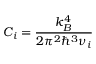<formula> <loc_0><loc_0><loc_500><loc_500>C _ { i } = \frac { k _ { B } ^ { 4 } } { 2 \pi ^ { 2 } \hbar { ^ } { 3 } \nu _ { i } }</formula> 